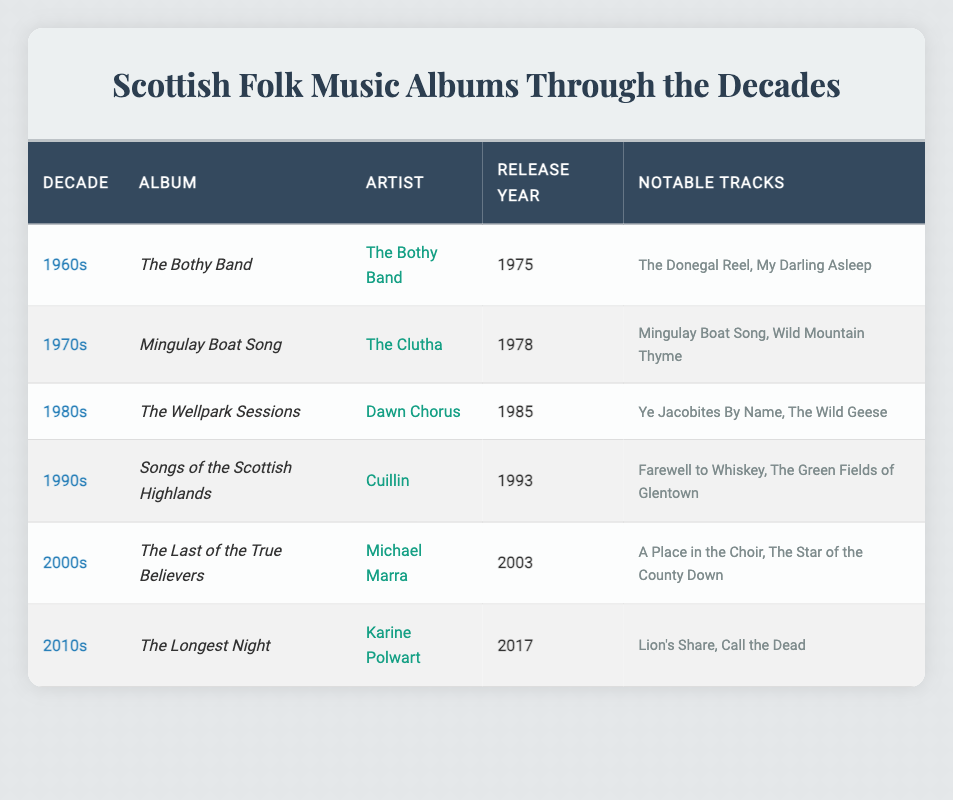What Scottish folk music album was released in 2003? The table lists "The Last of the True Believers" by Michael Marra as the album released in 2003 under the 2000s decade.
Answer: The Last of the True Believers Which artist has an album featuring "The Donegal Reel"? The album "The Bothy Band" features the track "The Donegal Reel," and it is by the artist The Bothy Band.
Answer: The Bothy Band How many notable tracks does the album "Songs of the Scottish Highlands" have? The album "Songs of the Scottish Highlands" has two notable tracks listed: "Farewell to Whiskey" and "The Green Fields of Glentown."
Answer: 2 Is "Lion's Share" a notable track from an album released in the 2010s? Yes, "Lion's Share" is a notable track from the album "The Longest Night," which was released by Karine Polwart in 2017, belonging to the 2010s decade.
Answer: Yes Which decade saw the release of the album "Mingulay Boat Song"? The table shows that the album "Mingulay Boat Song" was released in the 1970s in 1978.
Answer: 1970s How many albums listed in the table were released before 1990? The albums released before 1990 are "The Bothy Band" (1975), "Mingulay Boat Song" (1978), "The Wellpark Sessions" (1985), and "Songs of the Scottish Highlands" (1993). That's a total of four albums.
Answer: 4 Who is the artist of the album "The Wellpark Sessions"? According to the table, the artist of "The Wellpark Sessions" is Dawn Chorus.
Answer: Dawn Chorus What is the earliest release year for a Scottish folk music album in the table? The earliest release year listed is 1975 for the album "The Bothy Band."
Answer: 1975 How many albums were released in the 2000s? The table shows that there are two albums released in the 2000s: "The Last of the True Believers" (2003) by Michael Marra, therefore the count is one.
Answer: 1 